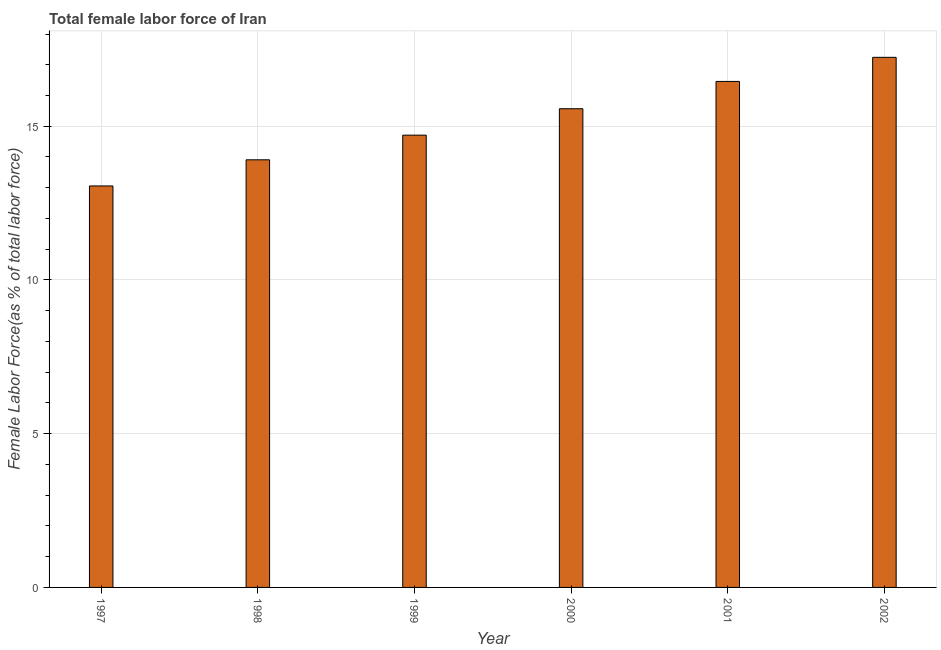What is the title of the graph?
Offer a very short reply. Total female labor force of Iran. What is the label or title of the Y-axis?
Give a very brief answer. Female Labor Force(as % of total labor force). What is the total female labor force in 1999?
Make the answer very short. 14.71. Across all years, what is the maximum total female labor force?
Ensure brevity in your answer.  17.24. Across all years, what is the minimum total female labor force?
Provide a succinct answer. 13.06. In which year was the total female labor force maximum?
Your response must be concise. 2002. In which year was the total female labor force minimum?
Your answer should be compact. 1997. What is the sum of the total female labor force?
Provide a succinct answer. 90.95. What is the difference between the total female labor force in 2000 and 2002?
Your response must be concise. -1.67. What is the average total female labor force per year?
Offer a terse response. 15.16. What is the median total female labor force?
Your answer should be very brief. 15.14. What is the ratio of the total female labor force in 1998 to that in 2001?
Provide a short and direct response. 0.84. Is the difference between the total female labor force in 1999 and 2000 greater than the difference between any two years?
Offer a terse response. No. What is the difference between the highest and the second highest total female labor force?
Make the answer very short. 0.78. What is the difference between the highest and the lowest total female labor force?
Make the answer very short. 4.18. How many years are there in the graph?
Your answer should be very brief. 6. Are the values on the major ticks of Y-axis written in scientific E-notation?
Provide a succinct answer. No. What is the Female Labor Force(as % of total labor force) of 1997?
Your response must be concise. 13.06. What is the Female Labor Force(as % of total labor force) in 1998?
Offer a very short reply. 13.91. What is the Female Labor Force(as % of total labor force) in 1999?
Your response must be concise. 14.71. What is the Female Labor Force(as % of total labor force) in 2000?
Offer a very short reply. 15.57. What is the Female Labor Force(as % of total labor force) of 2001?
Provide a succinct answer. 16.46. What is the Female Labor Force(as % of total labor force) of 2002?
Offer a very short reply. 17.24. What is the difference between the Female Labor Force(as % of total labor force) in 1997 and 1998?
Your answer should be compact. -0.85. What is the difference between the Female Labor Force(as % of total labor force) in 1997 and 1999?
Your response must be concise. -1.65. What is the difference between the Female Labor Force(as % of total labor force) in 1997 and 2000?
Make the answer very short. -2.51. What is the difference between the Female Labor Force(as % of total labor force) in 1997 and 2001?
Offer a very short reply. -3.4. What is the difference between the Female Labor Force(as % of total labor force) in 1997 and 2002?
Provide a succinct answer. -4.18. What is the difference between the Female Labor Force(as % of total labor force) in 1998 and 1999?
Offer a terse response. -0.8. What is the difference between the Female Labor Force(as % of total labor force) in 1998 and 2000?
Provide a short and direct response. -1.66. What is the difference between the Female Labor Force(as % of total labor force) in 1998 and 2001?
Provide a short and direct response. -2.55. What is the difference between the Female Labor Force(as % of total labor force) in 1998 and 2002?
Your answer should be compact. -3.33. What is the difference between the Female Labor Force(as % of total labor force) in 1999 and 2000?
Make the answer very short. -0.86. What is the difference between the Female Labor Force(as % of total labor force) in 1999 and 2001?
Make the answer very short. -1.75. What is the difference between the Female Labor Force(as % of total labor force) in 1999 and 2002?
Provide a short and direct response. -2.53. What is the difference between the Female Labor Force(as % of total labor force) in 2000 and 2001?
Give a very brief answer. -0.89. What is the difference between the Female Labor Force(as % of total labor force) in 2000 and 2002?
Ensure brevity in your answer.  -1.67. What is the difference between the Female Labor Force(as % of total labor force) in 2001 and 2002?
Make the answer very short. -0.78. What is the ratio of the Female Labor Force(as % of total labor force) in 1997 to that in 1998?
Your answer should be compact. 0.94. What is the ratio of the Female Labor Force(as % of total labor force) in 1997 to that in 1999?
Your answer should be very brief. 0.89. What is the ratio of the Female Labor Force(as % of total labor force) in 1997 to that in 2000?
Give a very brief answer. 0.84. What is the ratio of the Female Labor Force(as % of total labor force) in 1997 to that in 2001?
Ensure brevity in your answer.  0.79. What is the ratio of the Female Labor Force(as % of total labor force) in 1997 to that in 2002?
Provide a short and direct response. 0.76. What is the ratio of the Female Labor Force(as % of total labor force) in 1998 to that in 1999?
Your answer should be very brief. 0.94. What is the ratio of the Female Labor Force(as % of total labor force) in 1998 to that in 2000?
Provide a short and direct response. 0.89. What is the ratio of the Female Labor Force(as % of total labor force) in 1998 to that in 2001?
Keep it short and to the point. 0.84. What is the ratio of the Female Labor Force(as % of total labor force) in 1998 to that in 2002?
Make the answer very short. 0.81. What is the ratio of the Female Labor Force(as % of total labor force) in 1999 to that in 2000?
Your response must be concise. 0.94. What is the ratio of the Female Labor Force(as % of total labor force) in 1999 to that in 2001?
Your response must be concise. 0.89. What is the ratio of the Female Labor Force(as % of total labor force) in 1999 to that in 2002?
Your answer should be very brief. 0.85. What is the ratio of the Female Labor Force(as % of total labor force) in 2000 to that in 2001?
Provide a short and direct response. 0.95. What is the ratio of the Female Labor Force(as % of total labor force) in 2000 to that in 2002?
Offer a very short reply. 0.9. What is the ratio of the Female Labor Force(as % of total labor force) in 2001 to that in 2002?
Make the answer very short. 0.95. 